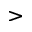<formula> <loc_0><loc_0><loc_500><loc_500>></formula> 